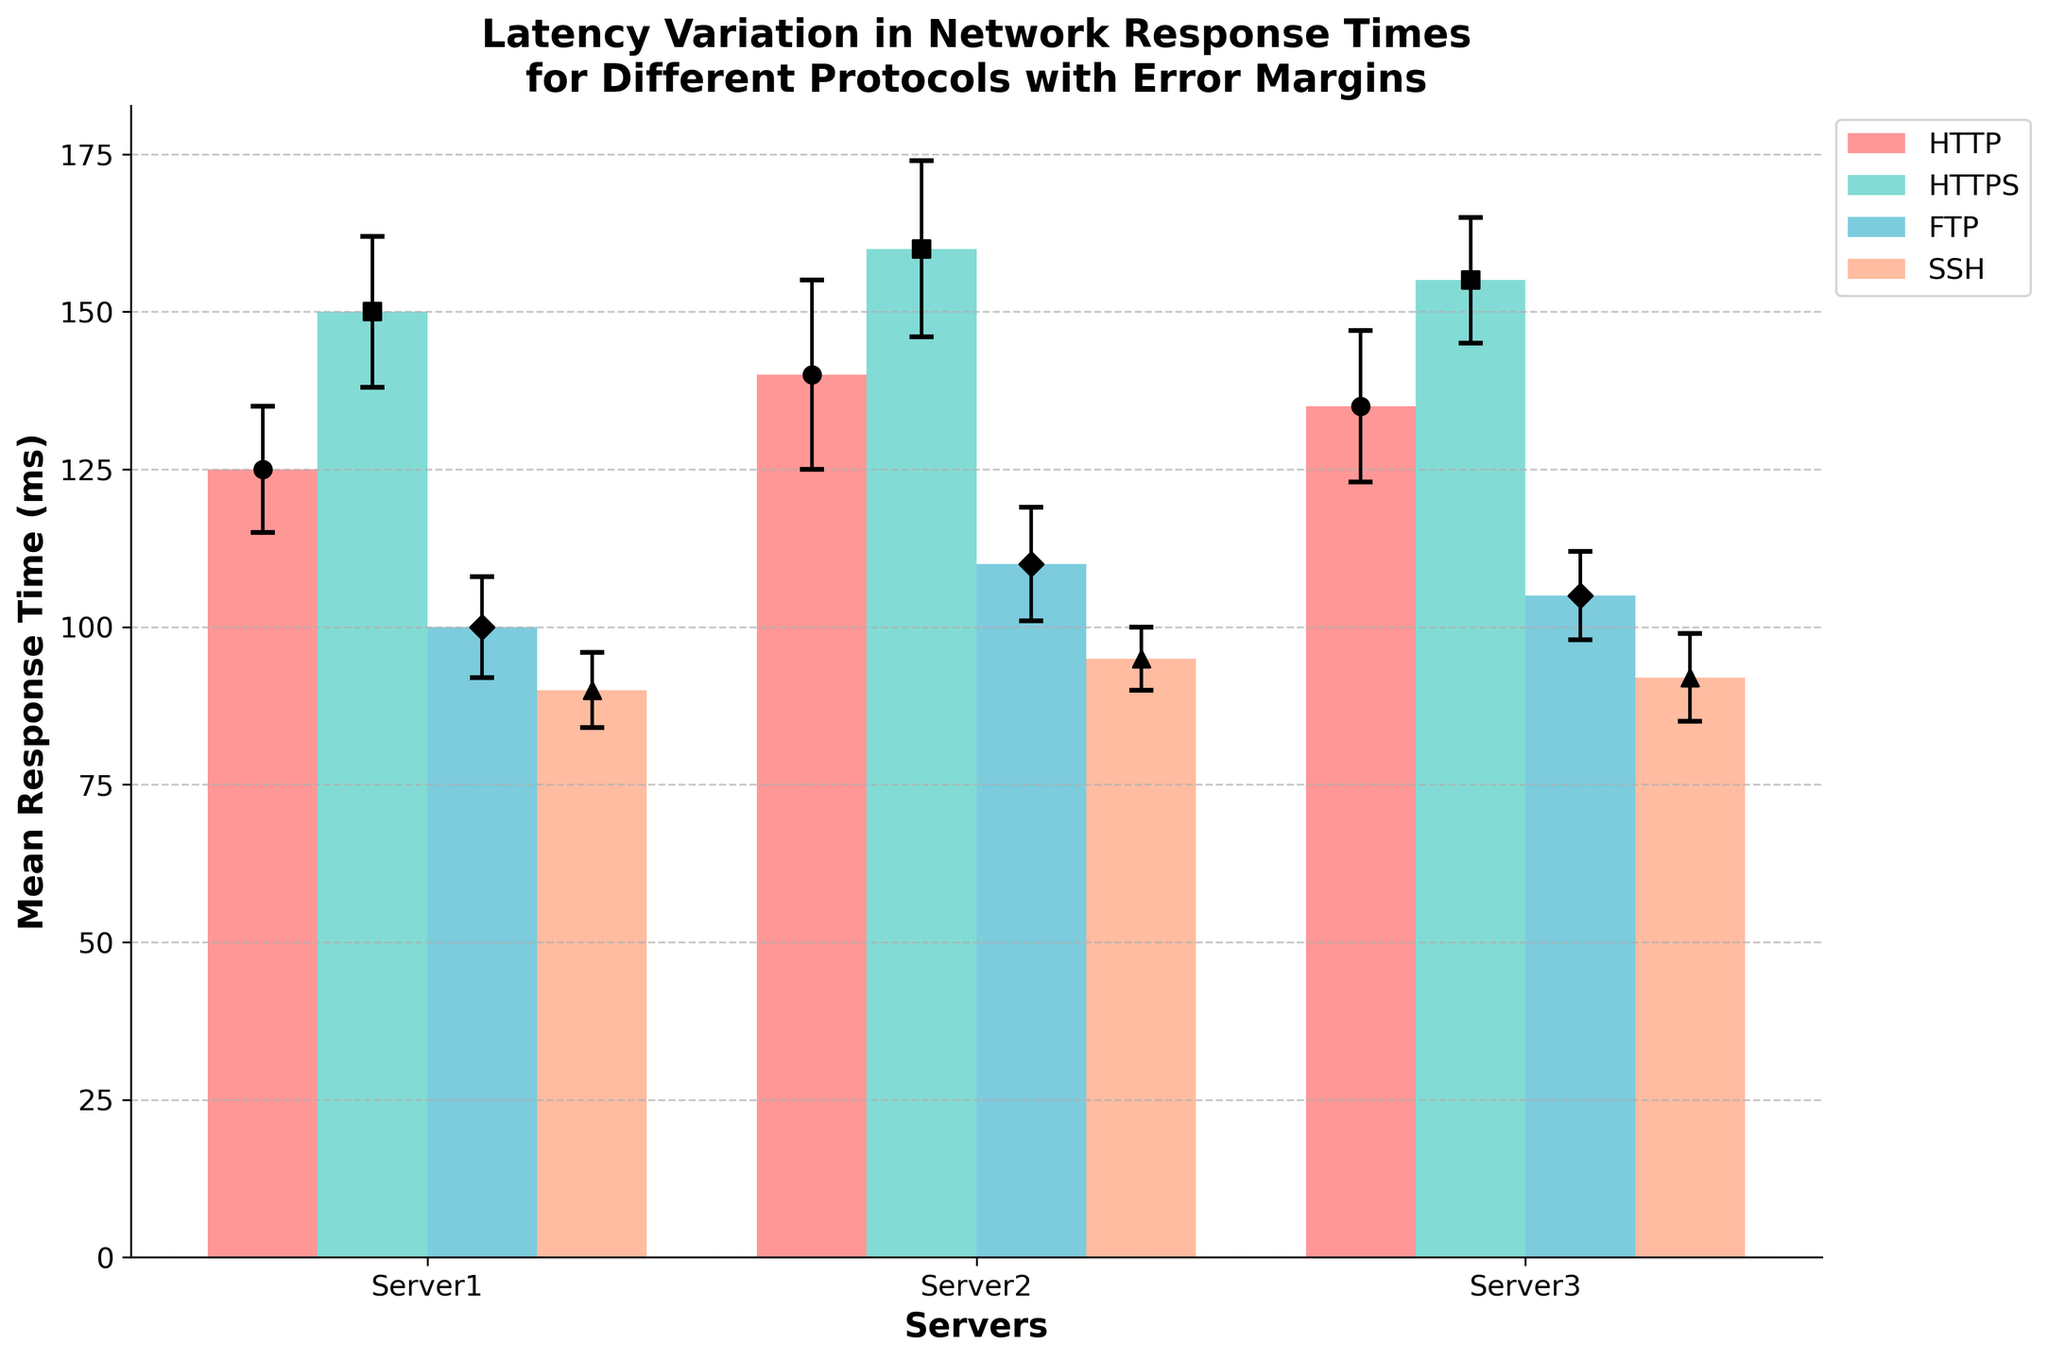Which protocol shows the highest mean response time on Server3? The highest mean response time on Server3 can be found by comparing the response times of all protocols on Server3. HTTP has 135 ms, HTTPS has 155 ms, FTP has 105 ms, and SSH has 92 ms. Therefore, HTTPS has the highest mean response time.
Answer: HTTPS What is the overall average mean response time across all servers for the FTP protocol? Calculate the average mean response time for FTP by summing the mean response times for Server1, Server2, and Server3, and then divide by the number of servers. (100 ms + 110 ms + 105 ms) / 3 = 105 ms.
Answer: 105 ms Which protocol has the smallest error margin on average? The smallest error margin on average can be found by calculating the average error margin for each protocol and comparing them. For HTTP: (10+15+12)/3 = 12.33 ms, HTTPS: (12+14+10)/3 = 12 ms, FTP: (8+9+7)/3 = 8 ms, SSH: (6+5+7)/3 = 6 ms. SSH has the smallest average error margin.
Answer: SSH Is the error margin for HTTPS on Server2 greater than that for HTTP on Server1? Compare the error margins directly: HTTPS on Server2 has an error margin of 14 ms, while HTTP on Server1 has an error margin of 10 ms. 14 ms is greater than 10 ms, so the error margin for HTTPS on Server2 is greater.
Answer: Yes What is the difference in mean response time between SSH on Server1 and FTP on Server1? Calculate the difference by subtracting the mean response time of SSH on Server1 from FTP on Server1. 100 ms (FTP) - 90 ms (SSH) = 10 ms.
Answer: 10 ms Which server has the lowest average mean response time across all protocols? Calculate the average response time for each server across all protocols and then compare them. Server1: (125+150+100+90)/4 = 116.25 ms, Server2: (140+160+110+95)/4 = 126.25 ms, Server3: (135+155+105+92)/4 = 121.75 ms. Server1 has the lowest average response time.
Answer: Server1 How does the mean response time for HTTP on Server2 compare to that for HTTPS on Server1? Compare the mean response times directly: HTTP on Server2 has 140 ms, while HTTPS on Server1 has 150 ms. 140 ms is less than 150 ms.
Answer: Less If you combine the mean response times for FTP across all servers, what is the total? Sum the mean response times for FTP for Server1, Server2, and Server3. 100 ms + 110 ms + 105 ms = 315 ms.
Answer: 315 ms What is the range of error margins for the SSH protocol? Calculate the range by subtracting the smallest error margin from the largest error margin for SSH. Range = 7 ms - 5 ms = 2 ms.
Answer: 2 ms 